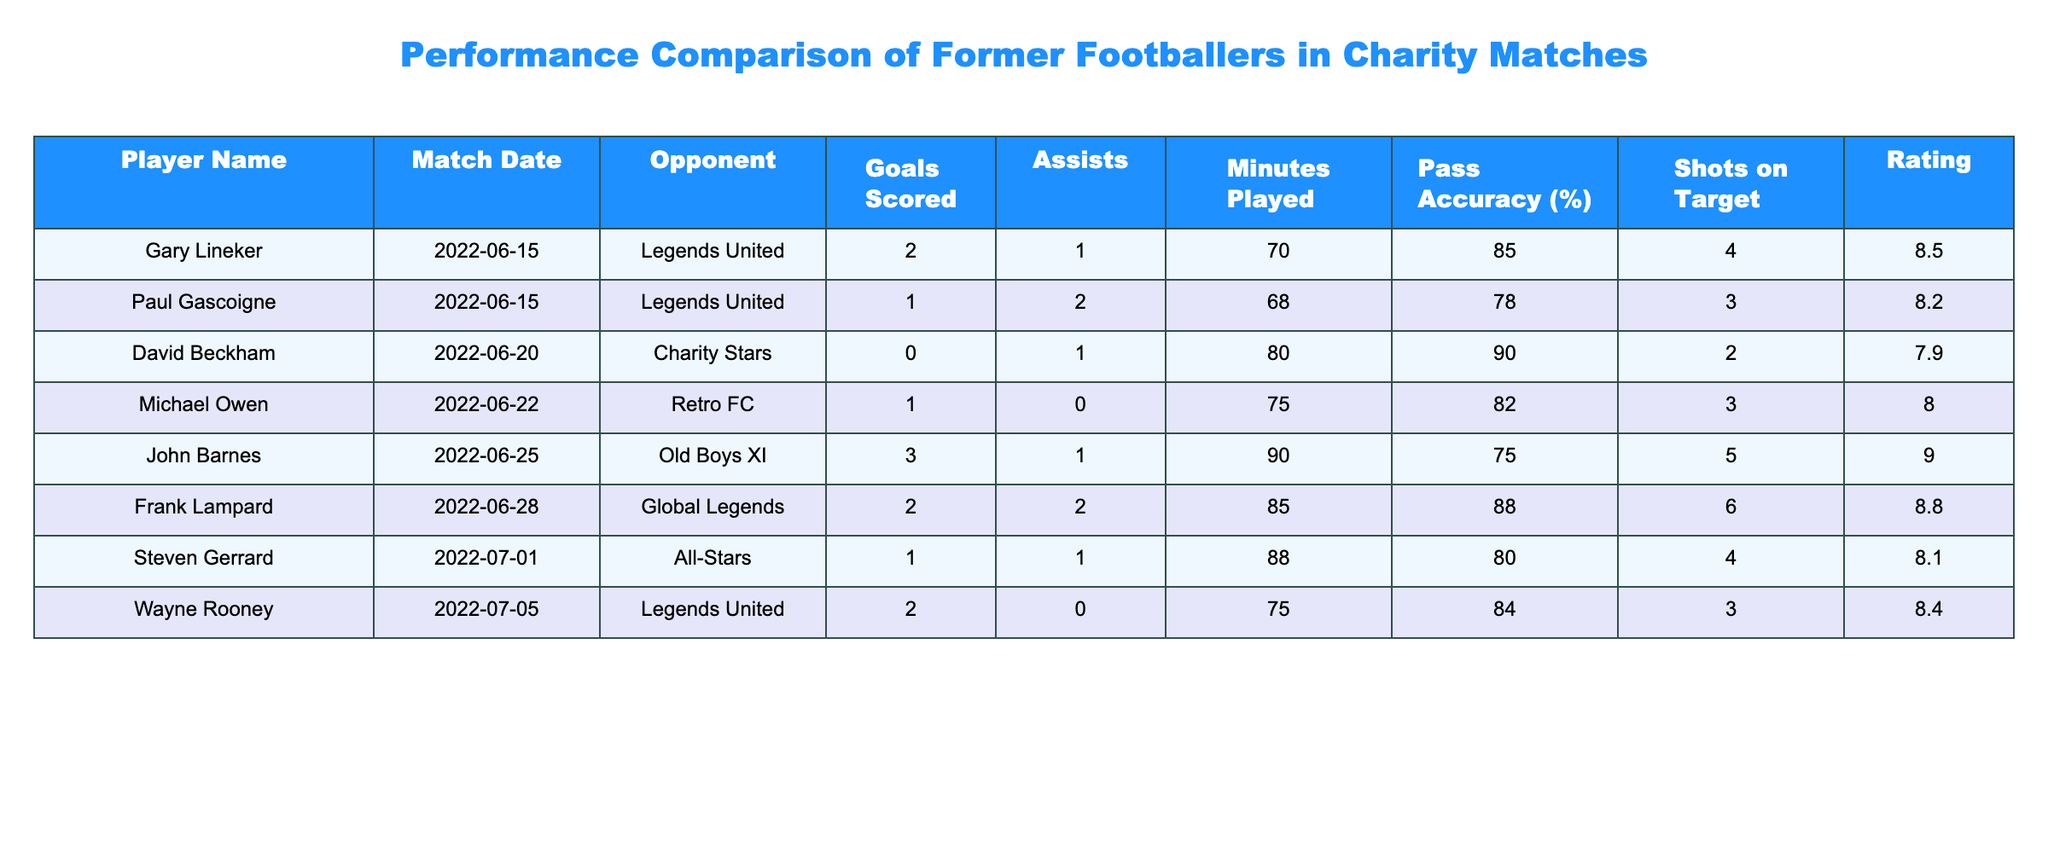What is the highest number of goals scored in a single match? The table shows that John Barnes scored the highest, with 3 goals in the match against Old Boys XI on 2022-06-25.
Answer: 3 Which player had the highest assist count? Frank Lampard and Paul Gascoigne both had the highest number of assists, with 2 assists each in their respective matches.
Answer: Frank Lampard and Paul Gascoigne What was David Beckham's pass accuracy percentage? According to the table, David Beckham had a pass accuracy of 90% in the match against Charity Stars on 2022-06-20.
Answer: 90% How many total goals did Gary Lineker and Wayne Rooney score combined? Gary Lineker scored 2 goals and Wayne Rooney scored 2 goals; thus, when added together, they scored a total of 2 + 2 = 4 goals.
Answer: 4 Did Steven Gerrard score more than one goal in any match? No, Steven Gerrard scored only 1 goal in the All-Stars match on 2022-07-01.
Answer: No Which player played the most minutes in a single match? John Barnes played 90 minutes in his match against Old Boys XI, which is the highest in the table.
Answer: 90 minutes What is the average rating of all players listed in the table? To find the average rating, sum the ratings: 8.5 + 8.2 + 7.9 + 8.0 + 9.0 + 8.8 + 8.1 + 8.4 = 68.9. Since there are 8 players, the average is 68.9 / 8 = 8.6125, which can be rounded to 8.6.
Answer: 8.6 Which player had the lowest rating? David Beckham had the lowest rating of 7.9 in the match against Charity Stars on 2022-06-20.
Answer: 7.9 Were there any players who did not score any goals? Yes, David Beckham did not score any goals in his match against Charity Stars.
Answer: Yes 